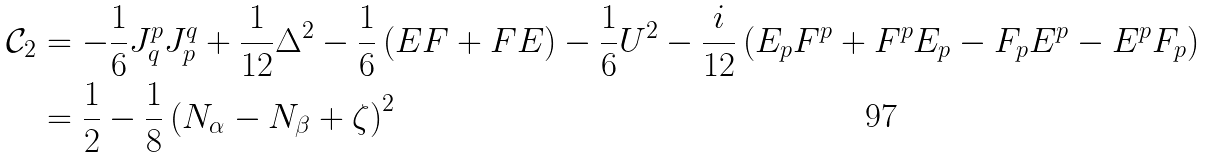<formula> <loc_0><loc_0><loc_500><loc_500>\mathcal { C } _ { 2 } & = - \frac { 1 } { 6 } J ^ { p } _ { q } J ^ { q } _ { p } + \frac { 1 } { 1 2 } \Delta ^ { 2 } - \frac { 1 } { 6 } \left ( E F + F E \right ) - \frac { 1 } { 6 } U ^ { 2 } - \frac { i } { 1 2 } \left ( E _ { p } F ^ { p } + F ^ { p } E _ { p } - F _ { p } E ^ { p } - E ^ { p } F _ { p } \right ) \\ & = \frac { 1 } { 2 } - \frac { 1 } { 8 } \left ( N _ { \alpha } - N _ { \beta } + \zeta \right ) ^ { 2 }</formula> 